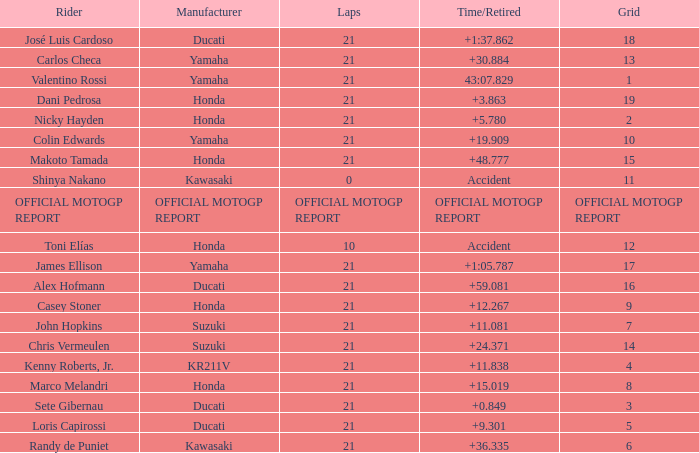What is the time/retired for the rider with the manufacturuer yamaha, grod of 1 and 21 total laps? 43:07.829. 